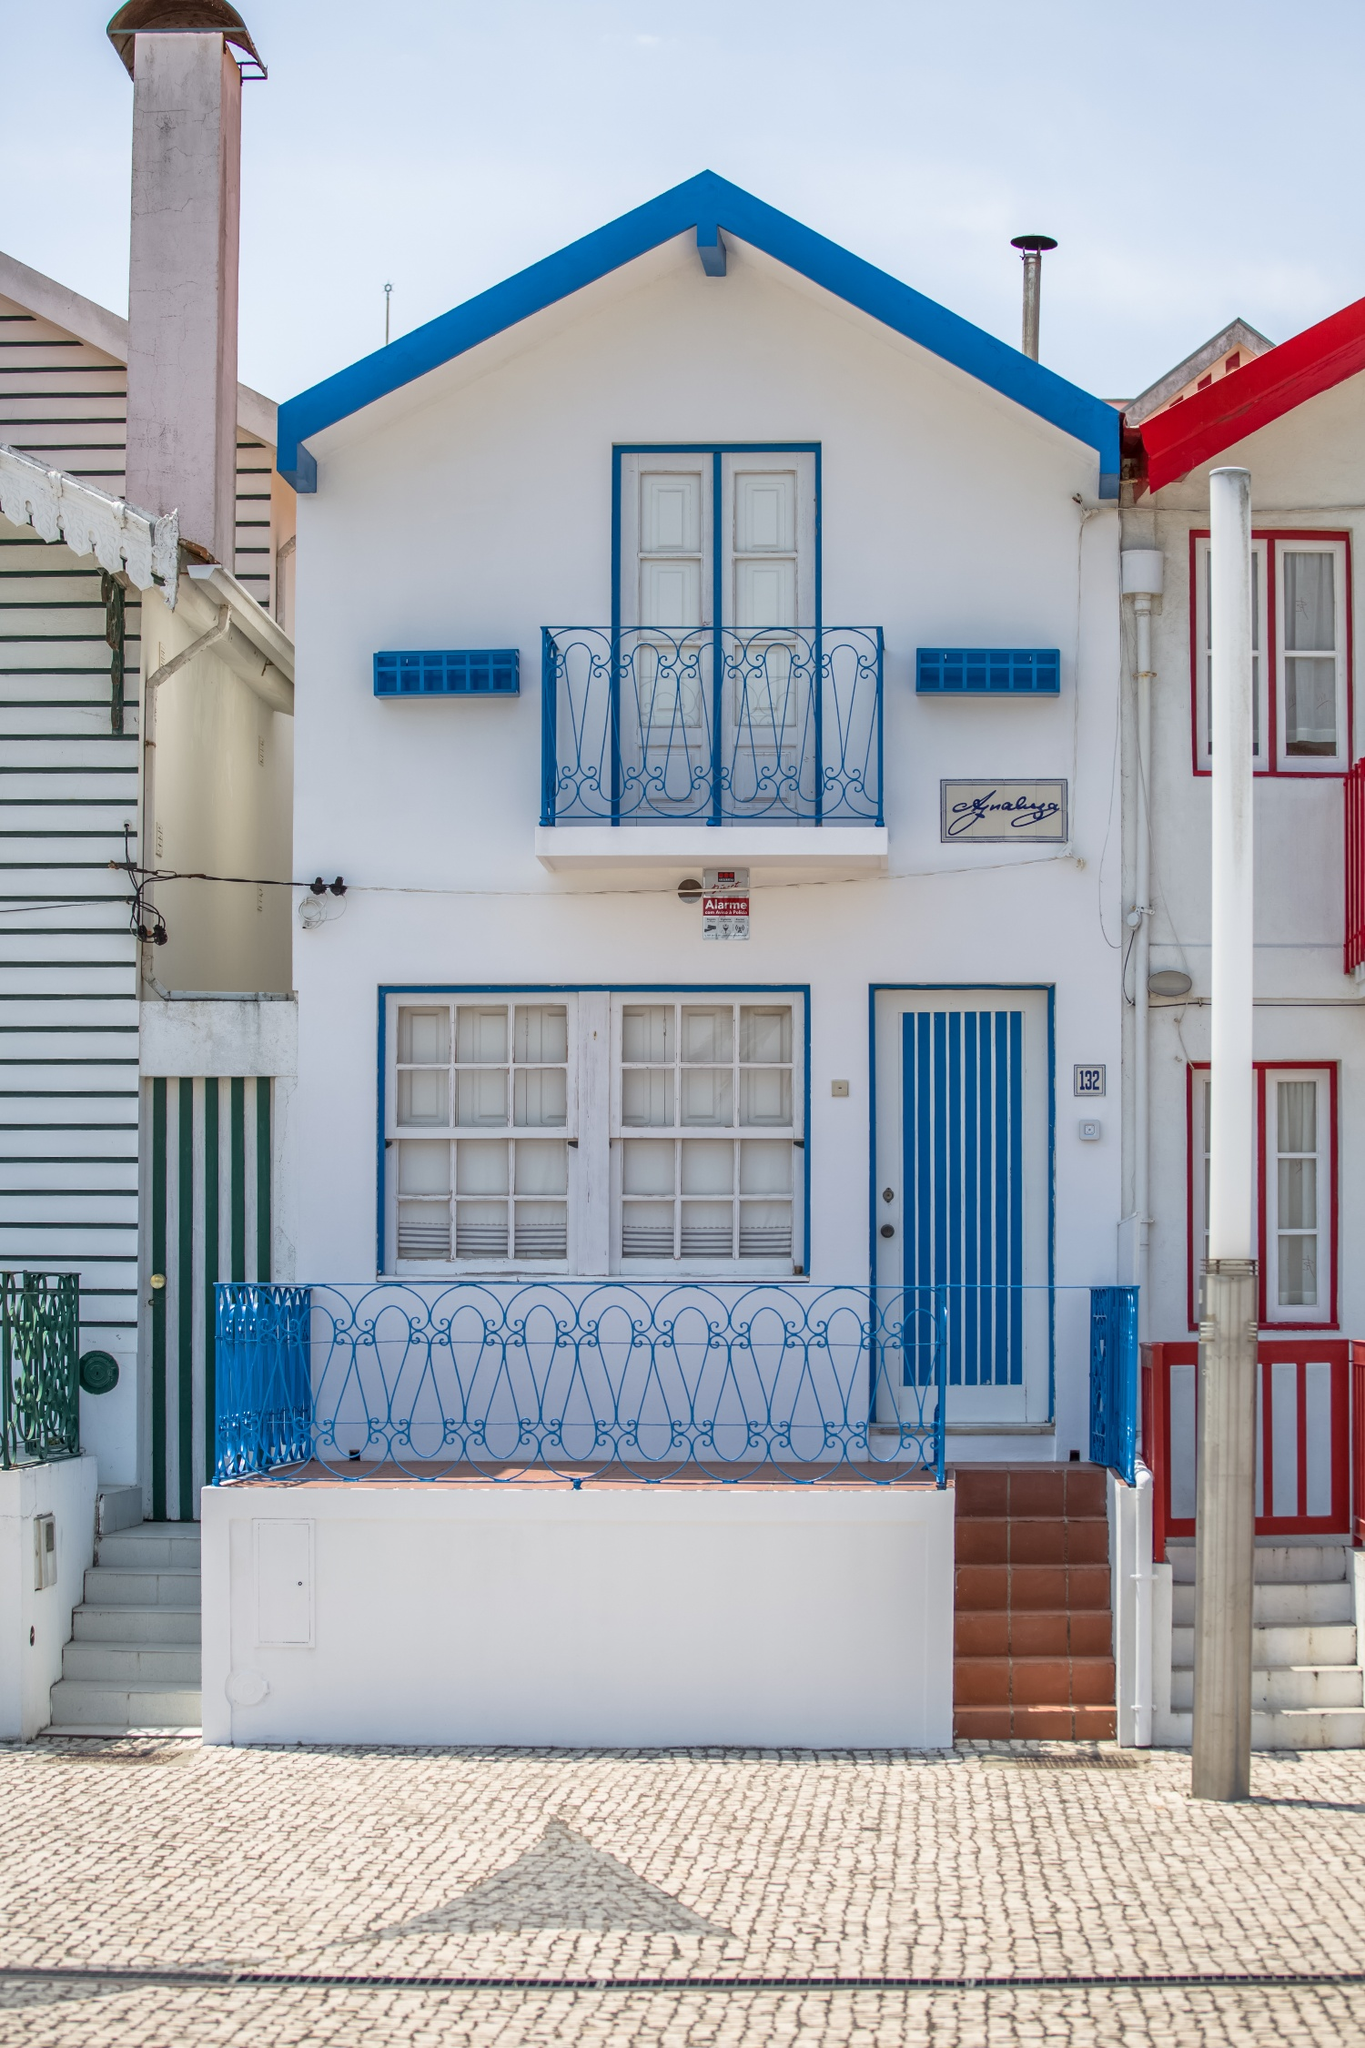What might be the practical reasons for the vibrant colors and design choices in this house? Vibrant colors in coastal towns often serve multiple practical purposes. Brightly colored homes can reflect sunlight, keeping interiors cool during sunny days, which is especially beneficial in warmer climates. Additionally, unique and vivid colors might help in navigation, allowing homes to be easily distinguishable for returning fishermen or during crowded festival seasons. The ornate designs, besides their aesthetic appeal, often provide enhanced ventilation and light, crucial for comfort in coastal areas. 